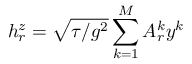<formula> <loc_0><loc_0><loc_500><loc_500>h _ { r } ^ { z } = \sqrt { { \tau / g ^ { 2 } } } \sum _ { k = 1 } ^ { M } A _ { r } ^ { k } y ^ { k }</formula> 